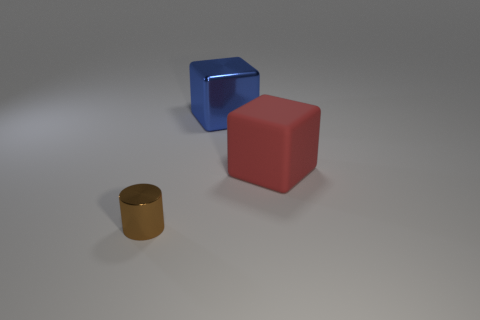Add 3 blue metal objects. How many objects exist? 6 Subtract 1 cylinders. How many cylinders are left? 0 Subtract all cylinders. How many objects are left? 2 Subtract all brown cylinders. Subtract all big blue metallic blocks. How many objects are left? 1 Add 1 red rubber objects. How many red rubber objects are left? 2 Add 3 big metal blocks. How many big metal blocks exist? 4 Subtract 1 brown cylinders. How many objects are left? 2 Subtract all cyan cubes. Subtract all red cylinders. How many cubes are left? 2 